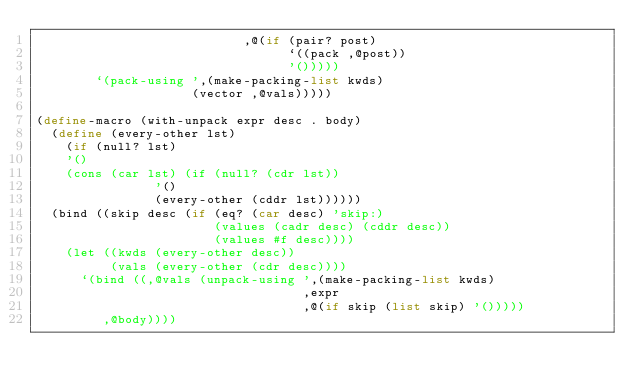<code> <loc_0><loc_0><loc_500><loc_500><_Scheme_>                            ,@(if (pair? post)
                                  `((pack ,@post))
                                  '()))))
        `(pack-using ',(make-packing-list kwds)
                     (vector ,@vals)))))

(define-macro (with-unpack expr desc . body)
  (define (every-other lst)
    (if (null? lst)
	'()
	(cons (car lst) (if (null? (cdr lst))
			    '()
			    (every-other (cddr lst))))))
  (bind ((skip desc (if (eq? (car desc) 'skip:)
                        (values (cadr desc) (cddr desc))
                        (values #f desc))))
    (let ((kwds (every-other desc))
          (vals (every-other (cdr desc))))
      `(bind ((,@vals (unpack-using ',(make-packing-list kwds) 
                                    ,expr 
                                    ,@(if skip (list skip) '()))))
         ,@body))))

</code> 